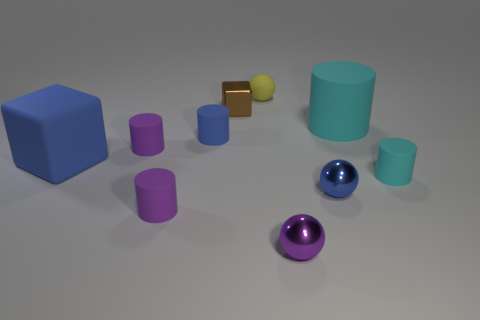Can you describe the array of shapes and colors presented in the image? Certainly! The image showcases a variety of geometric shapes including a blue cube, a gold and a smaller silver rectangle which could be metallic bars, a green spherical object, multiple cylinders in cyan and purple, and a shiny purple sphere. The colors range from vibrant blue to matte cyan, reflective gold, and a rich shade of purple, all resting on a neutral gray surface, creating a visually stimulating contrast.  Which object seems out of place in the pattern formed by the other shapes? While most of the objects participate in forming a somewhat scattered pattern, the gold and the smaller silver rectangular bars, due to their contrasting color and luster, catch the eye as they don't match the solid, uniform colors of the other shapes. They stand out amidst the collection of matte and glossy finished spheres and cylinders. 